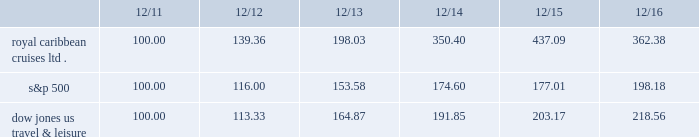Performance graph the following graph compares the total return , assuming reinvestment of dividends , on an investment in the company , based on performance of the company's common stock , with the total return of the standard & poor's 500 composite stock index and the dow jones united states travel and leisure index for a five year period by measuring the changes in common stock prices from december 31 , 2011 to december 31 , 2016. .
The stock performance graph assumes for comparison that the value of the company's common stock and of each index was $ 100 on december 31 , 2011 and that all dividends were reinvested .
Past performance is not necessarily an indicator of future results. .
What was the percentage increase in the stock performance of the royal caribbean cruises ltd . from 2012 to 2013? 
Computations: ((198.03 - 139.36) / 139.36)
Answer: 0.421. 